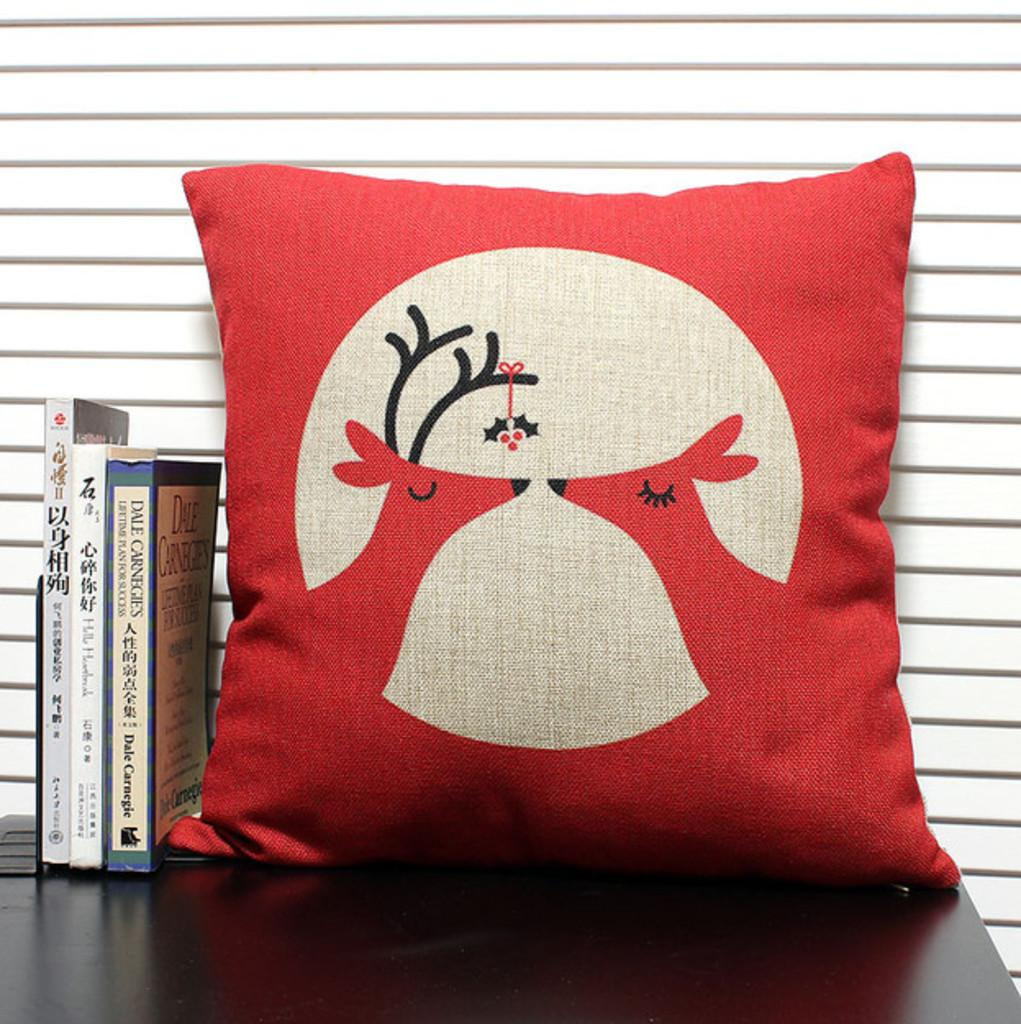What is the main object in the center of the image? There is a pillow in the center of the image. What other items are near the pillow? There are books beside the pillow. What piece of furniture is at the bottom of the image? There is a table at the bottom of the image. What can be seen in the background of the image? There is a wall in the background of the image. How many sheep can be seen in the image? There are no sheep present in the image. Is there a baseball game happening in the background of the image? There is no baseball game or any reference to baseball in the image. 